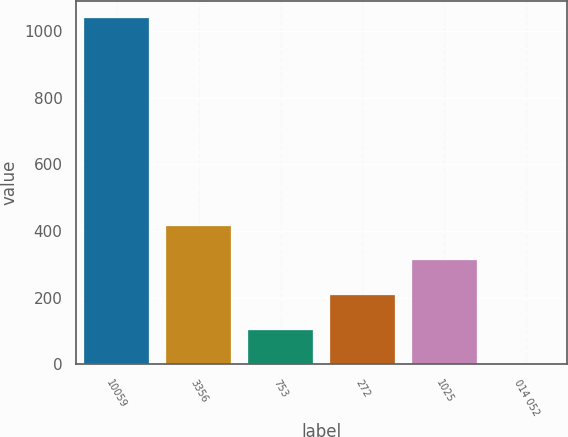<chart> <loc_0><loc_0><loc_500><loc_500><bar_chart><fcel>10059<fcel>3356<fcel>753<fcel>272<fcel>1025<fcel>014 052<nl><fcel>1038.9<fcel>415.73<fcel>104.12<fcel>207.99<fcel>311.86<fcel>0.25<nl></chart> 